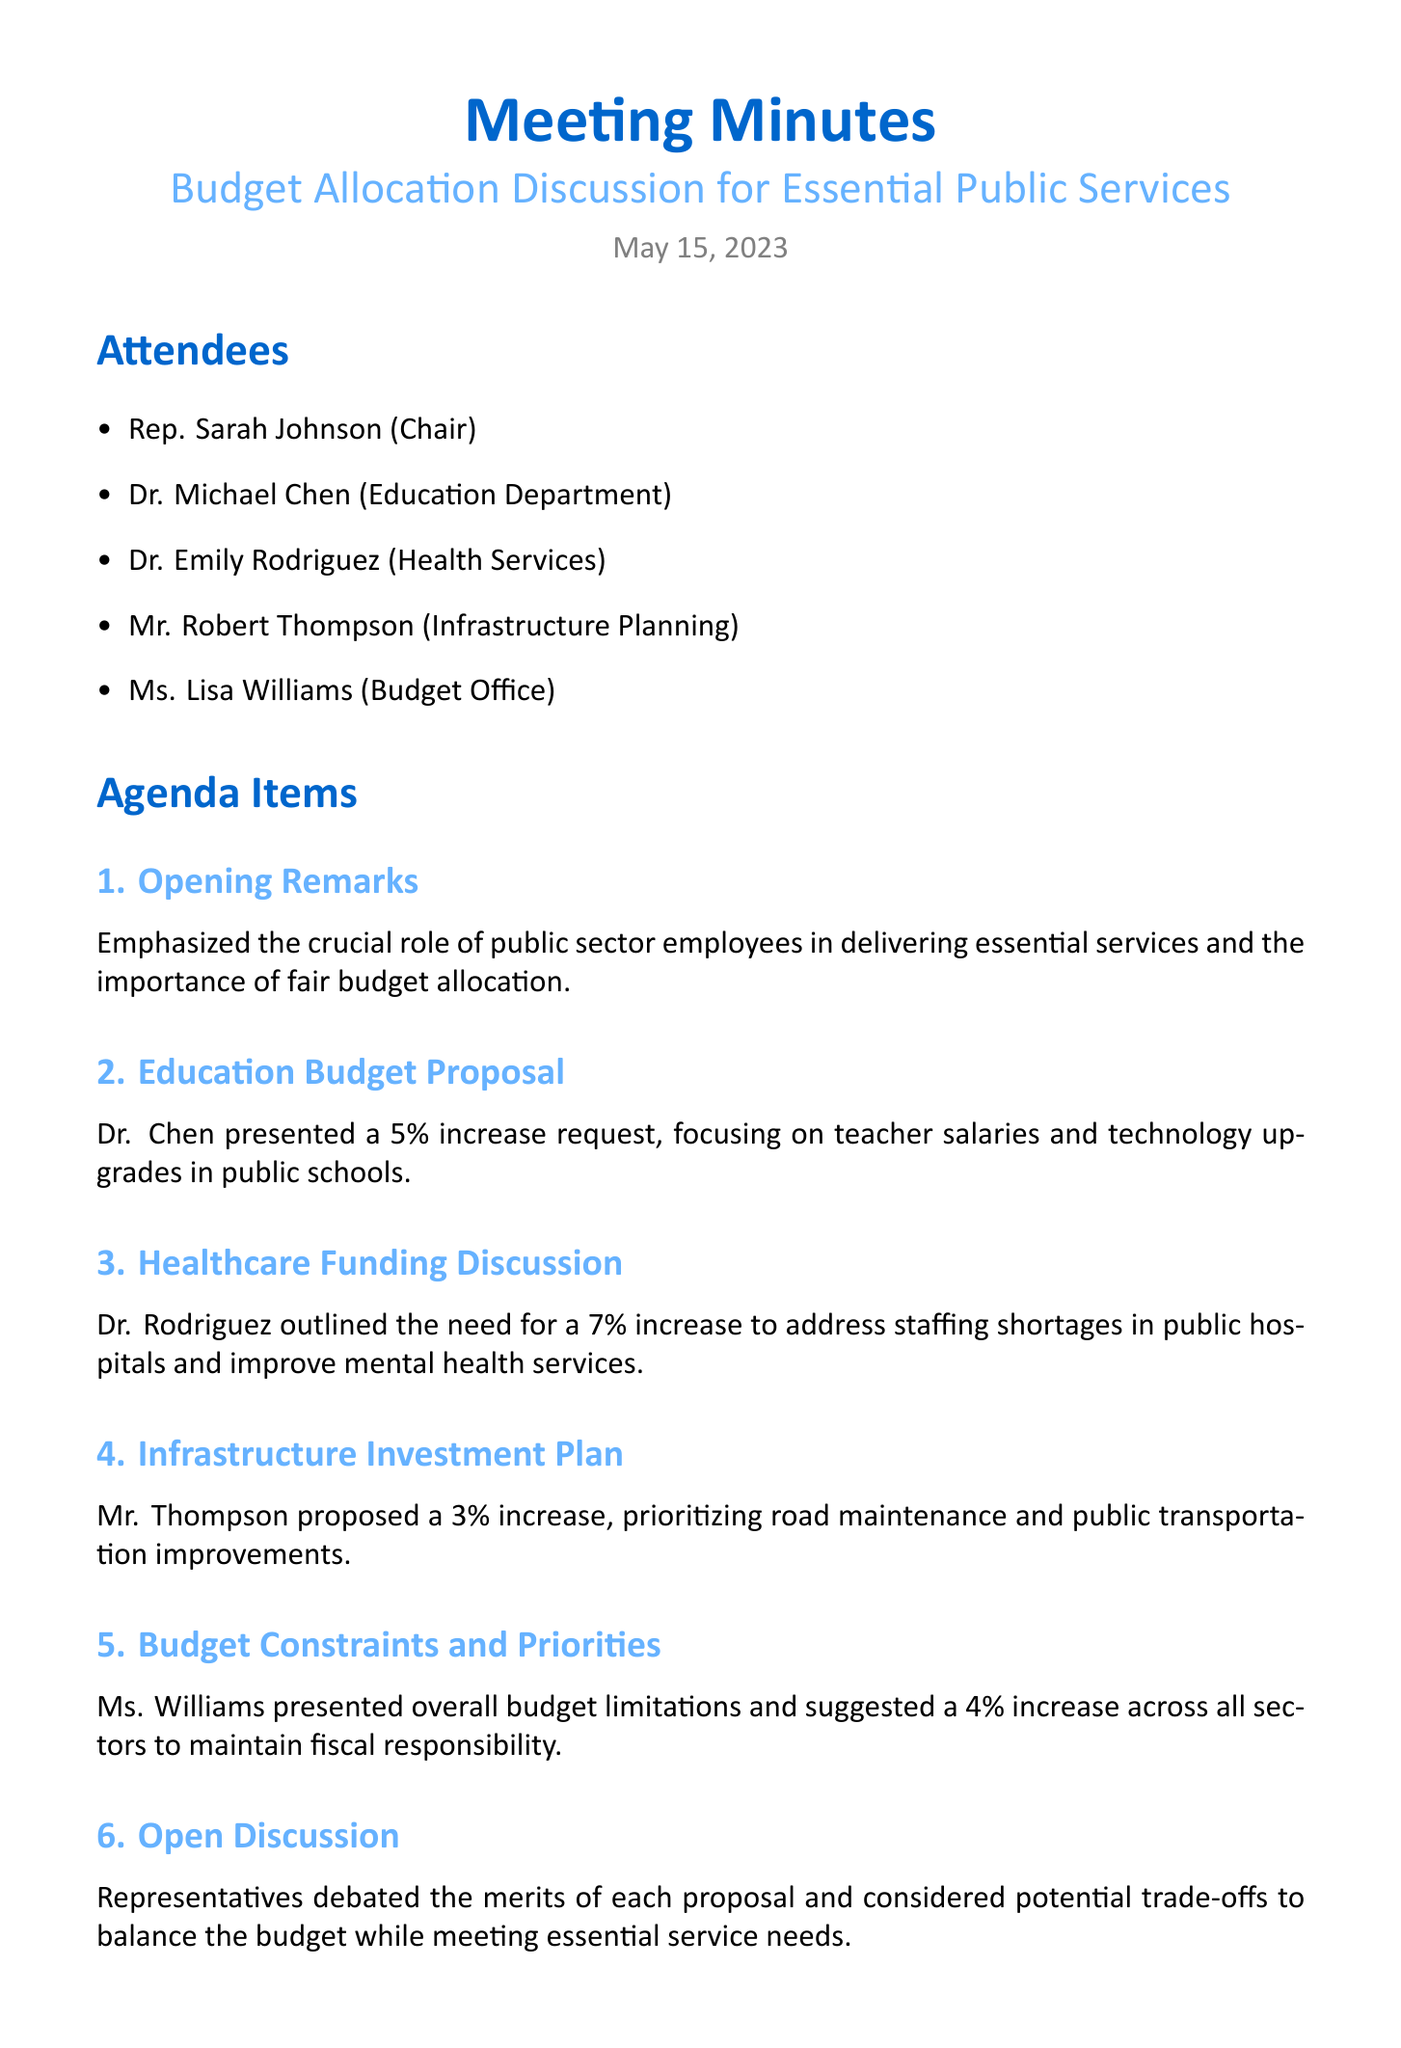What is the date of the meeting? The date of the meeting is explicitly stated in the document.
Answer: May 15, 2023 Who presented the education budget proposal? The document lists attendees and specifies who presented each agenda item.
Answer: Dr. Michael Chen What is the proposed increase percentage for healthcare funding? The content related to healthcare funding includes the requested increase percentage.
Answer: 7% What is the total proposed education and healthcare increase percentage combined? This requires adding the individual percentages mentioned in the key decisions section.
Answer: 4.5% What are the key subjects of the proposed budget allocations? The agenda items specifically mention areas of budget proposals impacting public services.
Answer: Education, healthcare, infrastructure What was emphasized in the opening remarks? The content of the opening remarks highlights crucial aspects of the discussion.
Answer: Role of public sector employees What is suggested as a budget increase across all sectors? The budget constraints section provides the suggested percentage increase across all sectors.
Answer: 4% What will the next step involve after the meeting? The next steps clearly outline what is planned following the meeting discussion.
Answer: Follow-up meetings 